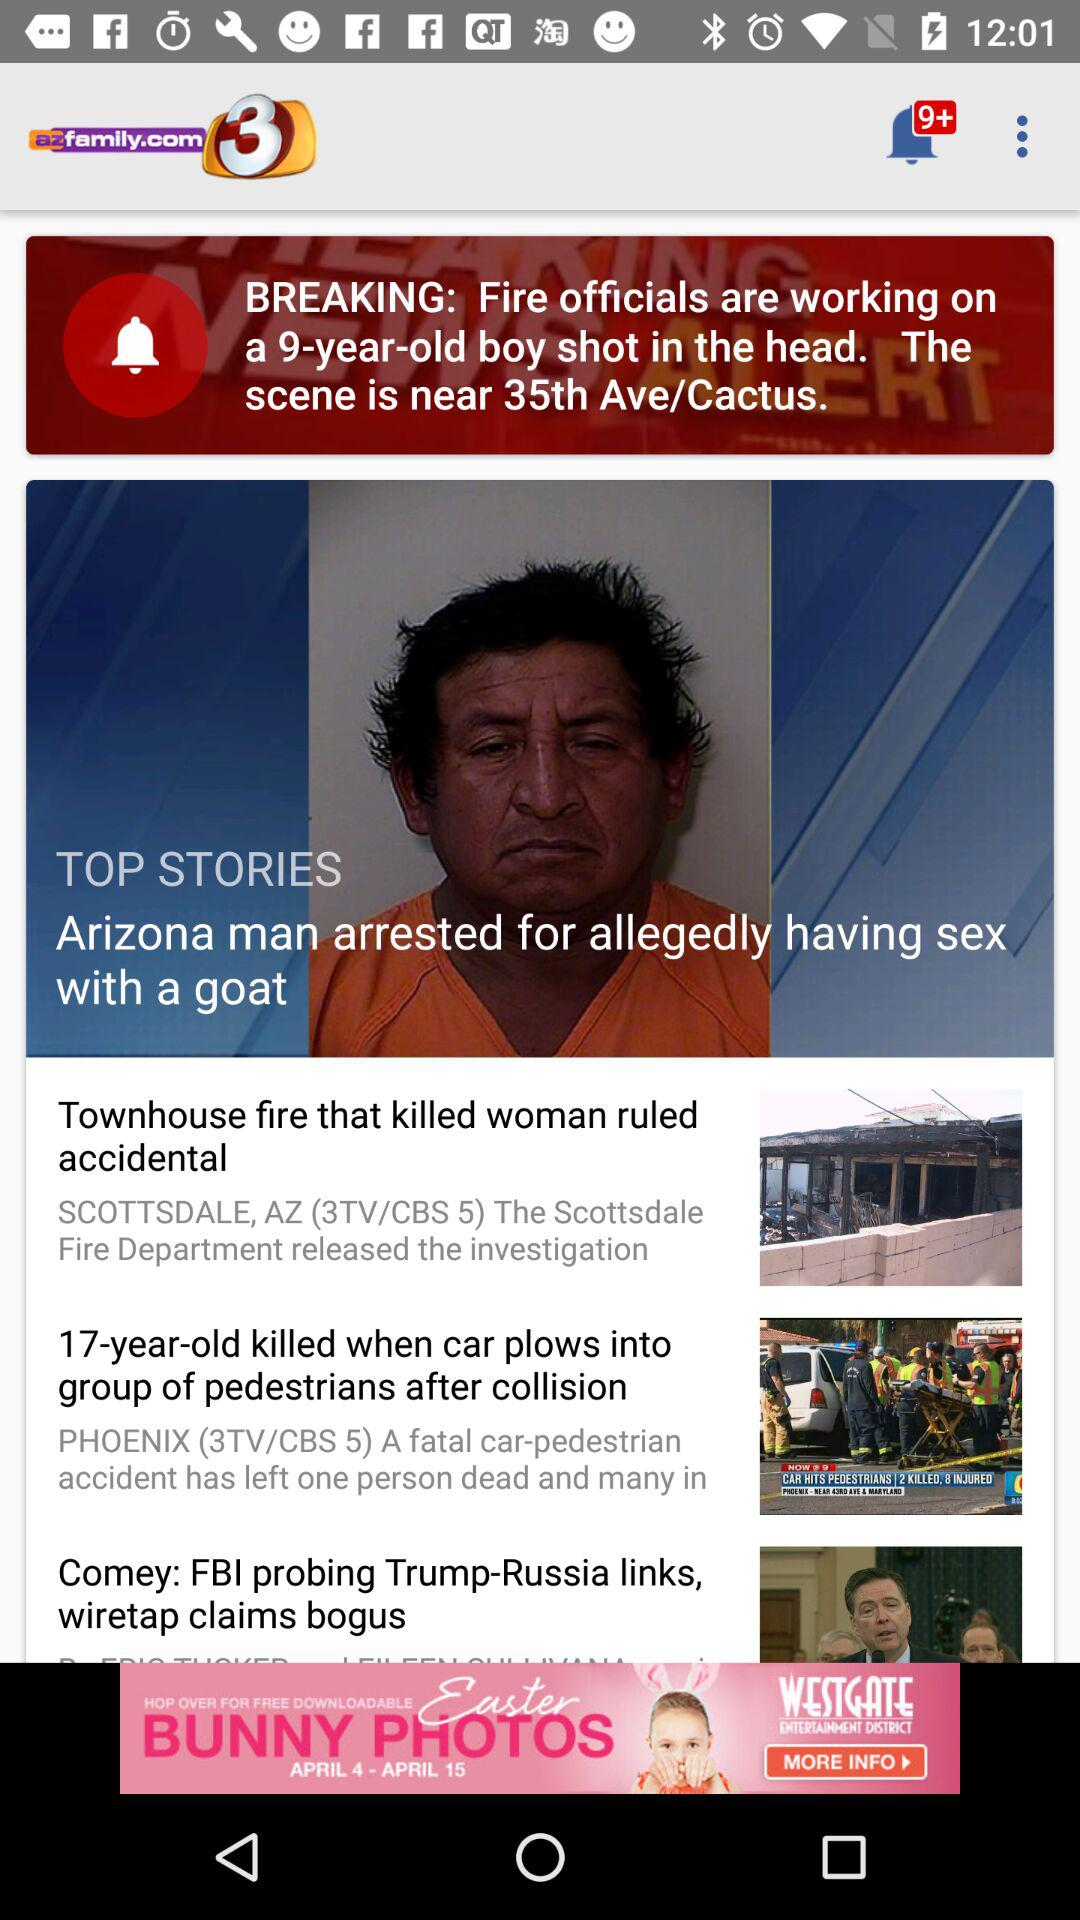How many unread notifications are there? There are more than 9 unread notifications. 